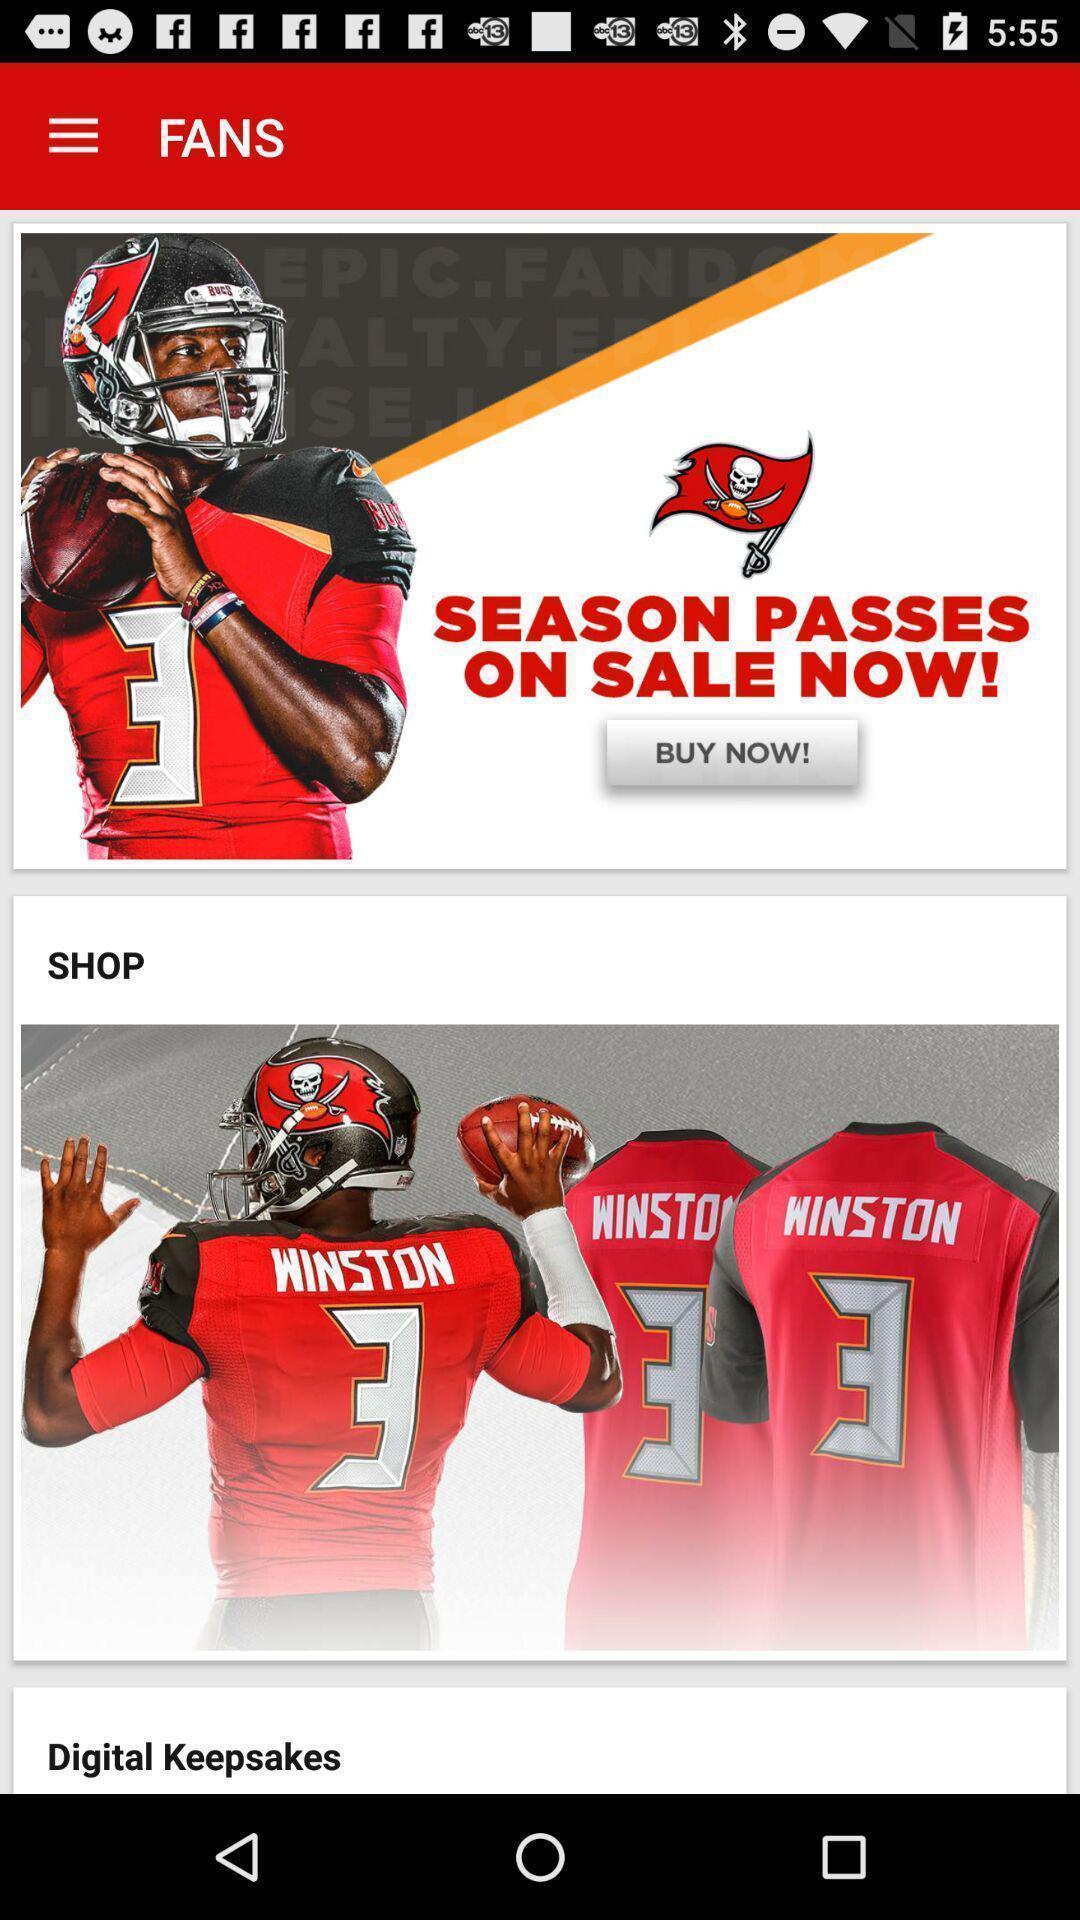Provide a detailed account of this screenshot. Screen shows images with options in a shopping app. 